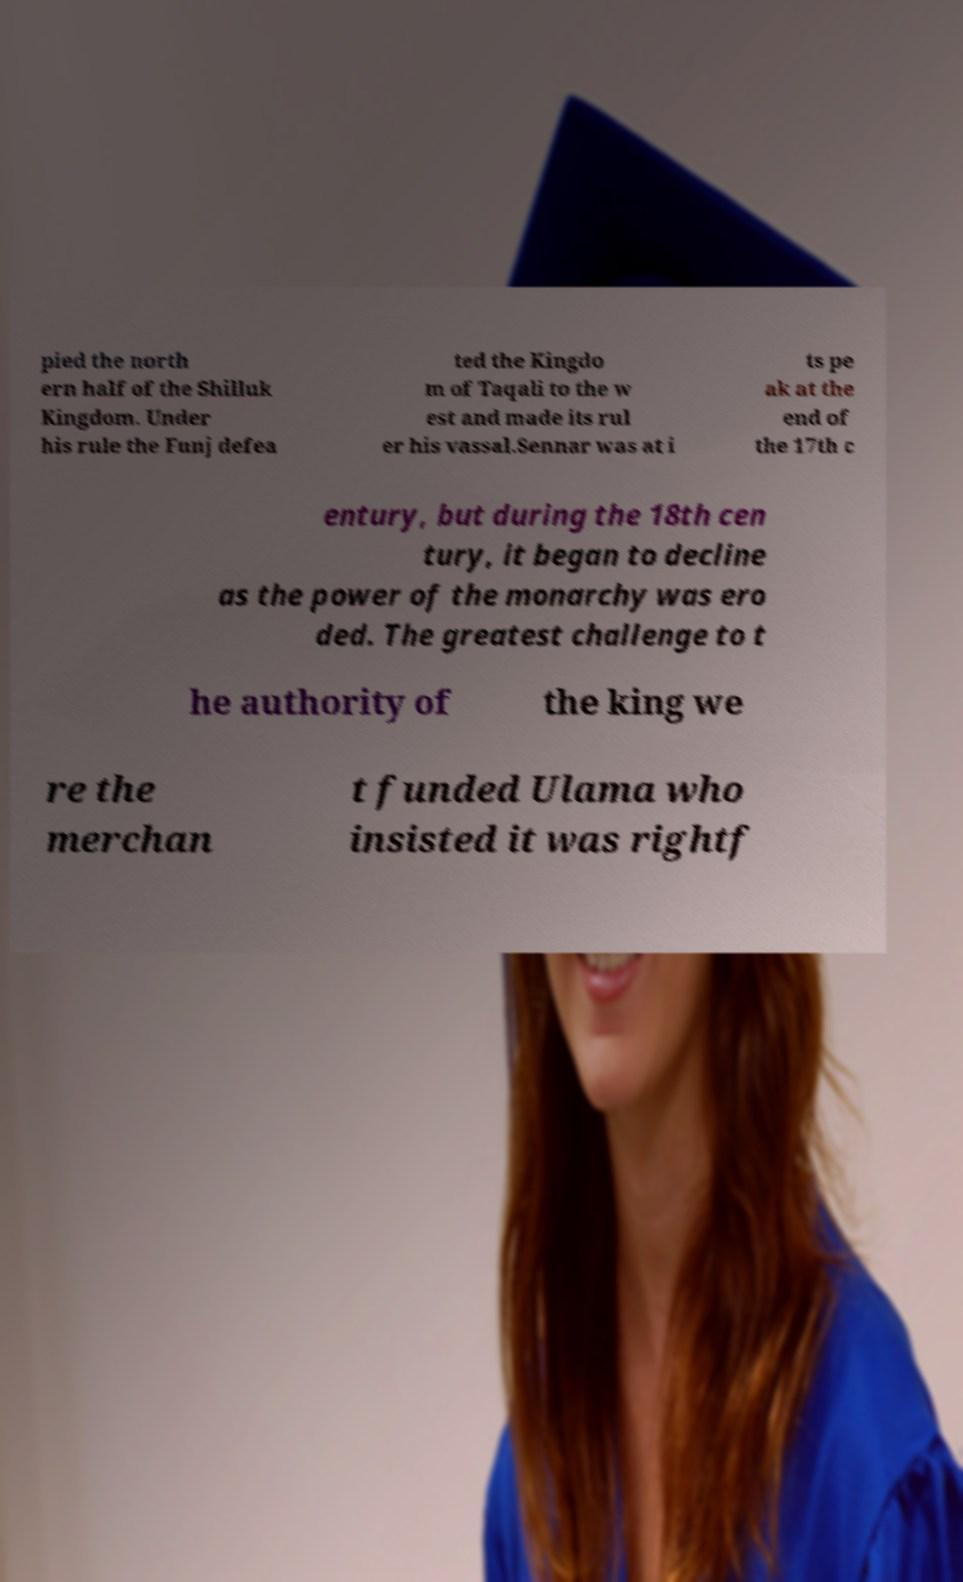Please read and relay the text visible in this image. What does it say? pied the north ern half of the Shilluk Kingdom. Under his rule the Funj defea ted the Kingdo m of Taqali to the w est and made its rul er his vassal.Sennar was at i ts pe ak at the end of the 17th c entury, but during the 18th cen tury, it began to decline as the power of the monarchy was ero ded. The greatest challenge to t he authority of the king we re the merchan t funded Ulama who insisted it was rightf 